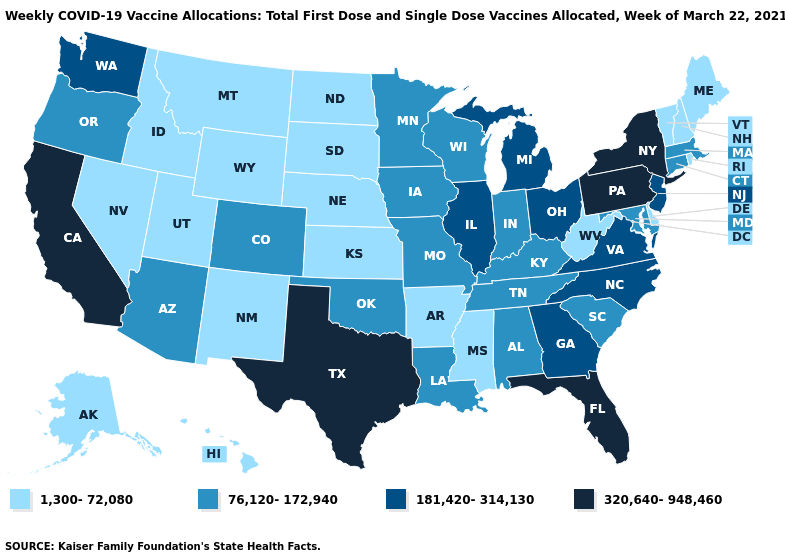Does the map have missing data?
Give a very brief answer. No. Which states have the lowest value in the West?
Concise answer only. Alaska, Hawaii, Idaho, Montana, Nevada, New Mexico, Utah, Wyoming. What is the value of Oregon?
Concise answer only. 76,120-172,940. Name the states that have a value in the range 181,420-314,130?
Concise answer only. Georgia, Illinois, Michigan, New Jersey, North Carolina, Ohio, Virginia, Washington. Name the states that have a value in the range 181,420-314,130?
Quick response, please. Georgia, Illinois, Michigan, New Jersey, North Carolina, Ohio, Virginia, Washington. Name the states that have a value in the range 181,420-314,130?
Concise answer only. Georgia, Illinois, Michigan, New Jersey, North Carolina, Ohio, Virginia, Washington. What is the value of Michigan?
Answer briefly. 181,420-314,130. What is the lowest value in the USA?
Short answer required. 1,300-72,080. Does New Hampshire have the lowest value in the USA?
Concise answer only. Yes. Which states have the lowest value in the USA?
Give a very brief answer. Alaska, Arkansas, Delaware, Hawaii, Idaho, Kansas, Maine, Mississippi, Montana, Nebraska, Nevada, New Hampshire, New Mexico, North Dakota, Rhode Island, South Dakota, Utah, Vermont, West Virginia, Wyoming. Name the states that have a value in the range 1,300-72,080?
Quick response, please. Alaska, Arkansas, Delaware, Hawaii, Idaho, Kansas, Maine, Mississippi, Montana, Nebraska, Nevada, New Hampshire, New Mexico, North Dakota, Rhode Island, South Dakota, Utah, Vermont, West Virginia, Wyoming. Is the legend a continuous bar?
Write a very short answer. No. Name the states that have a value in the range 320,640-948,460?
Give a very brief answer. California, Florida, New York, Pennsylvania, Texas. Name the states that have a value in the range 76,120-172,940?
Quick response, please. Alabama, Arizona, Colorado, Connecticut, Indiana, Iowa, Kentucky, Louisiana, Maryland, Massachusetts, Minnesota, Missouri, Oklahoma, Oregon, South Carolina, Tennessee, Wisconsin. Name the states that have a value in the range 320,640-948,460?
Write a very short answer. California, Florida, New York, Pennsylvania, Texas. 